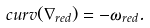Convert formula to latex. <formula><loc_0><loc_0><loc_500><loc_500>c u r v ( \nabla _ { r e d } ) = - \omega _ { r e d } .</formula> 